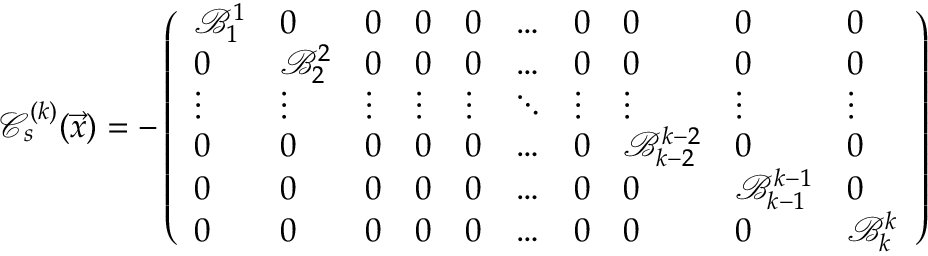<formula> <loc_0><loc_0><loc_500><loc_500>\mathcal { C } _ { s } ^ { ( k ) } ( \vec { x } ) = - \left ( \begin{array} { l l l l l l l l l l } { \mathcal { B } _ { 1 } ^ { 1 } } & { 0 } & { 0 } & { 0 } & { 0 } & { \dots } & { 0 } & { 0 } & { 0 } & { 0 } \\ { 0 } & { \mathcal { B } _ { 2 } ^ { 2 } } & { 0 } & { 0 } & { 0 } & { \dots } & { 0 } & { 0 } & { 0 } & { 0 } \\ { \vdots } & { \vdots } & { \vdots } & { \vdots } & { \vdots } & { \ddots } & { \vdots } & { \vdots } & { \vdots } & { \vdots } \\ { 0 } & { 0 } & { 0 } & { 0 } & { 0 } & { \dots } & { 0 } & { \mathcal { B } _ { k - 2 } ^ { k - 2 } } & { 0 } & { 0 } \\ { 0 } & { 0 } & { 0 } & { 0 } & { 0 } & { \dots } & { 0 } & { 0 } & { \mathcal { B } _ { k - 1 } ^ { k - 1 } } & { 0 } \\ { 0 } & { 0 } & { 0 } & { 0 } & { 0 } & { \dots } & { 0 } & { 0 } & { 0 } & { \mathcal { B } _ { k } ^ { k } } \end{array} \right )</formula> 